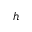<formula> <loc_0><loc_0><loc_500><loc_500>h</formula> 